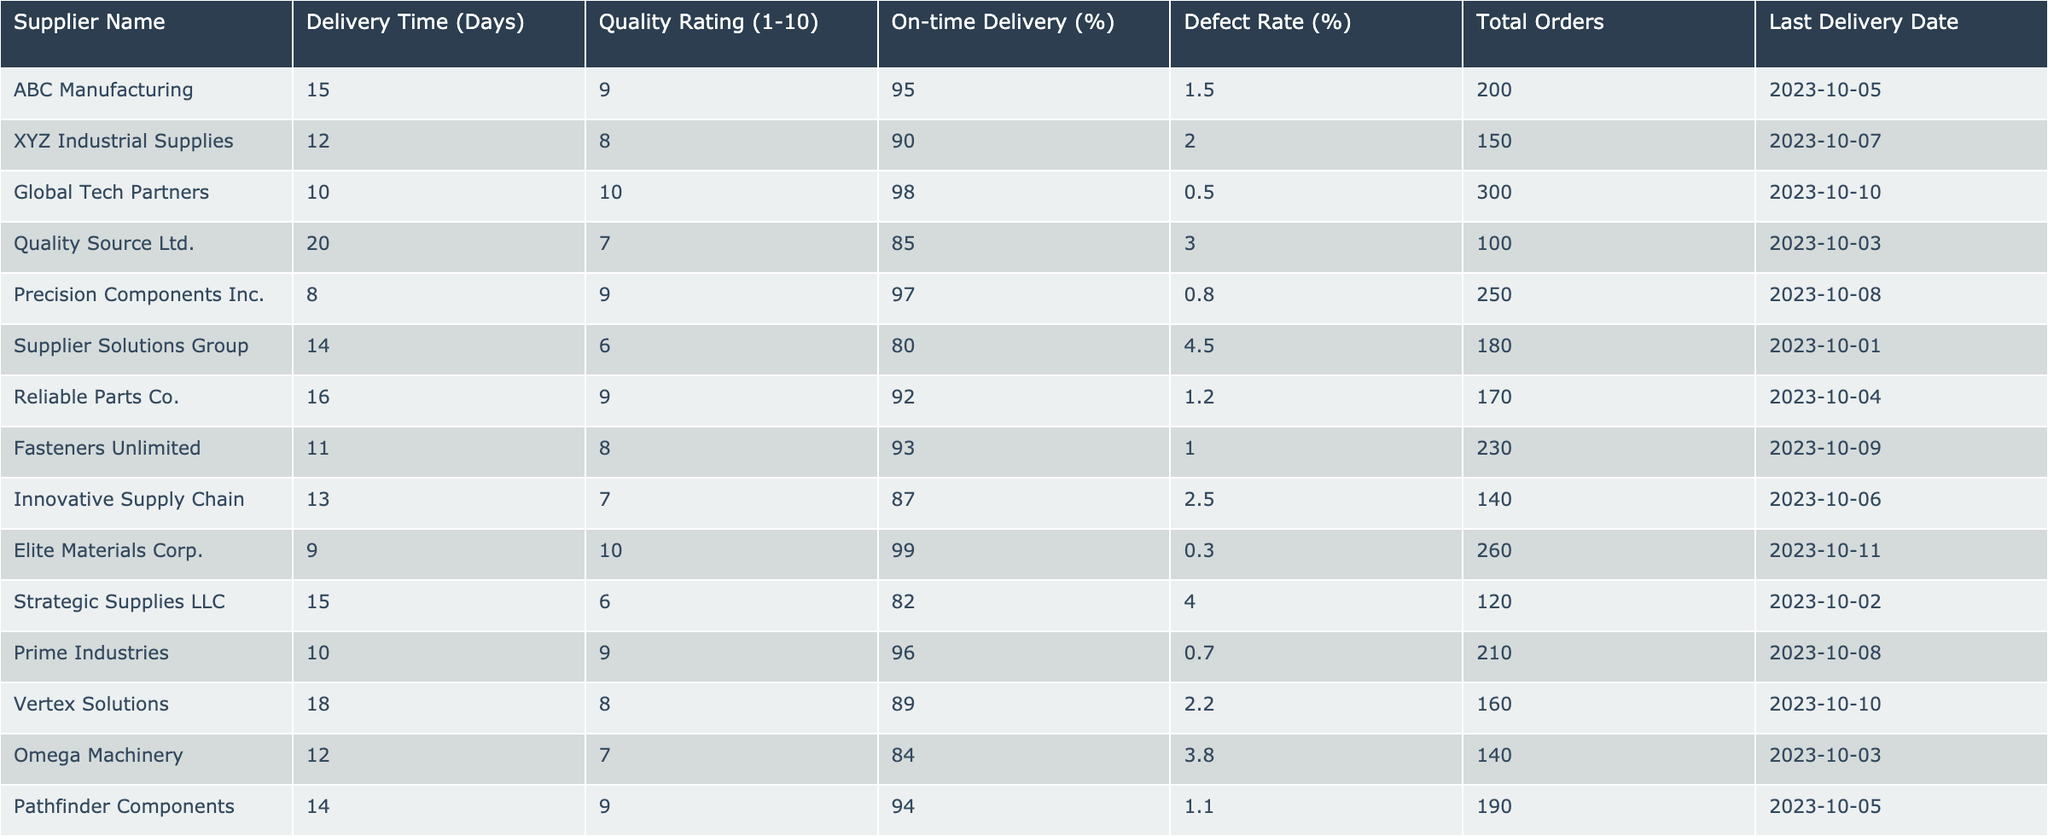What is the delivery time for Global Tech Partners? The table indicates that Global Tech Partners has a delivery time of 10 days listed under the "Delivery Time (Days)" column.
Answer: 10 days Which supplier has the highest quality rating? By comparing the "Quality Rating (1-10)" column, Global Tech Partners and Elite Materials Corp have the highest ratings of 10, making them tie for the best quality rating.
Answer: Global Tech Partners and Elite Materials Corp What is the average delivery time of all suppliers? To find the average, sum the delivery times (15 + 12 + 10 + 20 + 8 + 14 + 16 + 11 + 13 + 9 + 15 + 10 + 18 + 12 + 14) =  240, and divide by the number of suppliers (15), which equals 16 days.
Answer: 16 days Is Reliable Parts Co. delivering on-time more than 90% of the time? Checking the "On-time Delivery (%)" column shows Reliable Parts Co. has an on-time delivery rate of 92%, which is greater than 90%.
Answer: Yes How many suppliers have a defect rate less than 1%? By checking the "Defect Rate (%)" column, only Elite Materials Corp (0.3%) and Global Tech Partners (0.5%) have defect rates under 1%, totaling 2 suppliers.
Answer: 2 suppliers What is the difference in on-time delivery percentage between the best and worst suppliers? The best on-time delivery percentage is 99% (Elite Materials Corp), and the worst is 80% (Supplier Solutions Group). The difference is 99 - 80 = 19%.
Answer: 19% Which supplier has the most total orders? The "Total Orders" column shows Global Tech Partners with 300 total orders, which is the maximum among all suppliers listed.
Answer: Global Tech Partners If we consider only suppliers with a quality rating of 9 or higher, what is the average defect rate? The defect rates for suppliers with a rating of 9 or higher are: Global Tech Partners (0.5%), Precision Components Inc. (0.8%), Reliable Parts Co. (1.2%), Elite Materials Corp. (0.3%), and Prime Industries (0.7%). The average defect rate is (0.5 + 0.8 + 1.2 + 0.3 + 0.7) / 5 = 0.7%.
Answer: 0.7% How many suppliers have a last delivery date after October 5, 2023? Examining the last delivery dates, the suppliers with dates after October 5 are: XYZ Industrial Supplies (October 7), Global Tech Partners (October 10), Fasteners Unlimited (October 9), Vertex Solutions (October 10), and Elite Materials Corp (October 11), totaling 5 suppliers.
Answer: 5 suppliers What percentage of total orders have a delivery time of more than 15 days? The suppliers with a delivery time over 15 days are ABC Manufacturing (200 orders), Quality Source Ltd. (100 orders), and Vertex Solutions (160 orders). The total orders for these suppliers are 200 + 100 + 160 = 460. The total orders in the table is 200 + 150 + 300 + 100 + 250 + 180 + 170 + 230 + 140 + 260 + 120 + 210 + 160 + 140 + 190 = 2650. Hence, the percentage is (460 / 2650) * 100 = 17.36%.
Answer: 17.36% 